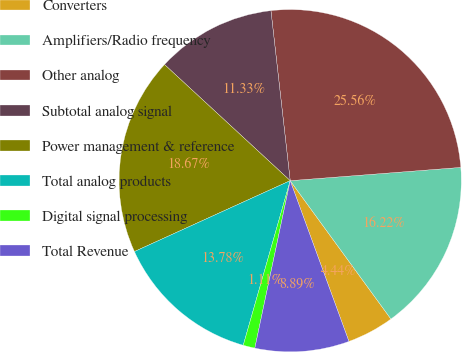Convert chart. <chart><loc_0><loc_0><loc_500><loc_500><pie_chart><fcel>Converters<fcel>Amplifiers/Radio frequency<fcel>Other analog<fcel>Subtotal analog signal<fcel>Power management & reference<fcel>Total analog products<fcel>Digital signal processing<fcel>Total Revenue<nl><fcel>4.44%<fcel>16.22%<fcel>25.56%<fcel>11.33%<fcel>18.67%<fcel>13.78%<fcel>1.11%<fcel>8.89%<nl></chart> 